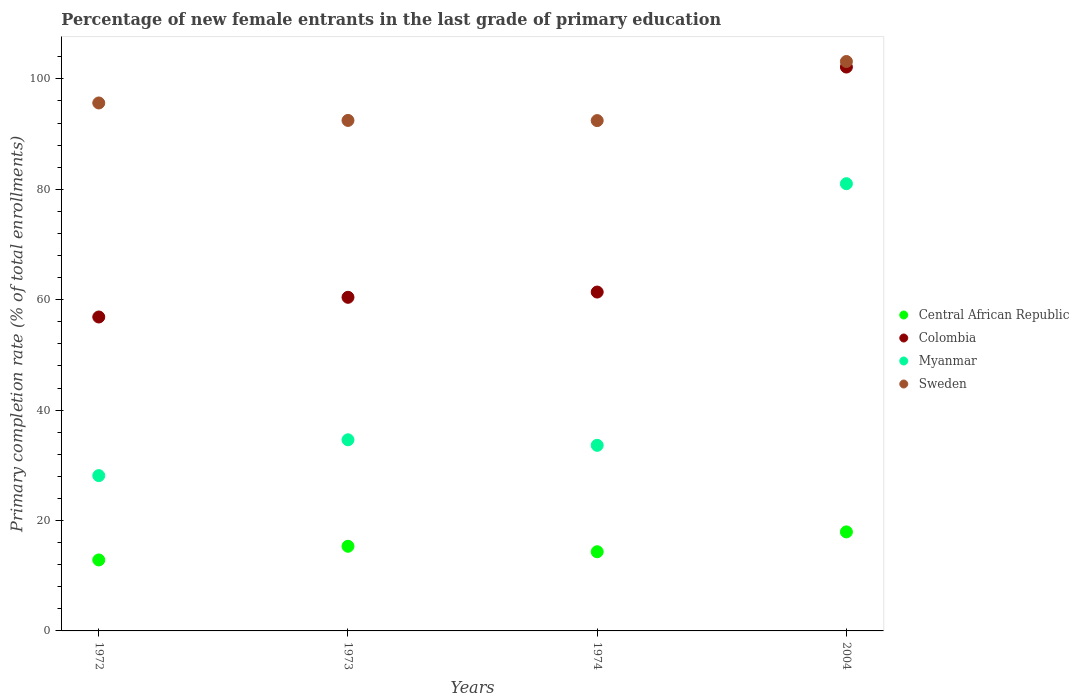Is the number of dotlines equal to the number of legend labels?
Make the answer very short. Yes. What is the percentage of new female entrants in Colombia in 1973?
Make the answer very short. 60.43. Across all years, what is the maximum percentage of new female entrants in Central African Republic?
Ensure brevity in your answer.  17.94. Across all years, what is the minimum percentage of new female entrants in Sweden?
Offer a terse response. 92.44. What is the total percentage of new female entrants in Central African Republic in the graph?
Provide a short and direct response. 60.47. What is the difference between the percentage of new female entrants in Colombia in 1972 and that in 2004?
Give a very brief answer. -45.28. What is the difference between the percentage of new female entrants in Myanmar in 1972 and the percentage of new female entrants in Sweden in 1974?
Ensure brevity in your answer.  -64.31. What is the average percentage of new female entrants in Colombia per year?
Ensure brevity in your answer.  70.21. In the year 1972, what is the difference between the percentage of new female entrants in Myanmar and percentage of new female entrants in Sweden?
Offer a very short reply. -67.5. What is the ratio of the percentage of new female entrants in Central African Republic in 1972 to that in 1974?
Your answer should be very brief. 0.9. Is the percentage of new female entrants in Sweden in 1972 less than that in 1973?
Make the answer very short. No. Is the difference between the percentage of new female entrants in Myanmar in 1972 and 2004 greater than the difference between the percentage of new female entrants in Sweden in 1972 and 2004?
Offer a terse response. No. What is the difference between the highest and the second highest percentage of new female entrants in Colombia?
Your answer should be compact. 40.76. What is the difference between the highest and the lowest percentage of new female entrants in Central African Republic?
Offer a very short reply. 5.08. In how many years, is the percentage of new female entrants in Colombia greater than the average percentage of new female entrants in Colombia taken over all years?
Give a very brief answer. 1. Is the sum of the percentage of new female entrants in Central African Republic in 1973 and 2004 greater than the maximum percentage of new female entrants in Sweden across all years?
Offer a very short reply. No. Is it the case that in every year, the sum of the percentage of new female entrants in Myanmar and percentage of new female entrants in Colombia  is greater than the sum of percentage of new female entrants in Central African Republic and percentage of new female entrants in Sweden?
Offer a very short reply. No. Does the percentage of new female entrants in Myanmar monotonically increase over the years?
Offer a very short reply. No. Is the percentage of new female entrants in Sweden strictly greater than the percentage of new female entrants in Colombia over the years?
Keep it short and to the point. Yes. Is the percentage of new female entrants in Myanmar strictly less than the percentage of new female entrants in Colombia over the years?
Provide a short and direct response. Yes. What is the difference between two consecutive major ticks on the Y-axis?
Your answer should be very brief. 20. Does the graph contain any zero values?
Offer a terse response. No. Where does the legend appear in the graph?
Keep it short and to the point. Center right. How are the legend labels stacked?
Provide a succinct answer. Vertical. What is the title of the graph?
Make the answer very short. Percentage of new female entrants in the last grade of primary education. What is the label or title of the X-axis?
Your response must be concise. Years. What is the label or title of the Y-axis?
Make the answer very short. Primary completion rate (% of total enrollments). What is the Primary completion rate (% of total enrollments) in Central African Republic in 1972?
Provide a succinct answer. 12.86. What is the Primary completion rate (% of total enrollments) of Colombia in 1972?
Keep it short and to the point. 56.87. What is the Primary completion rate (% of total enrollments) of Myanmar in 1972?
Keep it short and to the point. 28.13. What is the Primary completion rate (% of total enrollments) of Sweden in 1972?
Your answer should be very brief. 95.64. What is the Primary completion rate (% of total enrollments) of Central African Republic in 1973?
Your response must be concise. 15.33. What is the Primary completion rate (% of total enrollments) in Colombia in 1973?
Provide a short and direct response. 60.43. What is the Primary completion rate (% of total enrollments) of Myanmar in 1973?
Your answer should be very brief. 34.62. What is the Primary completion rate (% of total enrollments) in Sweden in 1973?
Provide a succinct answer. 92.47. What is the Primary completion rate (% of total enrollments) in Central African Republic in 1974?
Provide a succinct answer. 14.34. What is the Primary completion rate (% of total enrollments) in Colombia in 1974?
Provide a succinct answer. 61.39. What is the Primary completion rate (% of total enrollments) in Myanmar in 1974?
Keep it short and to the point. 33.62. What is the Primary completion rate (% of total enrollments) in Sweden in 1974?
Offer a very short reply. 92.44. What is the Primary completion rate (% of total enrollments) of Central African Republic in 2004?
Your answer should be compact. 17.94. What is the Primary completion rate (% of total enrollments) of Colombia in 2004?
Offer a very short reply. 102.14. What is the Primary completion rate (% of total enrollments) of Myanmar in 2004?
Your answer should be very brief. 81.01. What is the Primary completion rate (% of total enrollments) of Sweden in 2004?
Provide a succinct answer. 103.15. Across all years, what is the maximum Primary completion rate (% of total enrollments) of Central African Republic?
Keep it short and to the point. 17.94. Across all years, what is the maximum Primary completion rate (% of total enrollments) in Colombia?
Provide a short and direct response. 102.14. Across all years, what is the maximum Primary completion rate (% of total enrollments) in Myanmar?
Offer a terse response. 81.01. Across all years, what is the maximum Primary completion rate (% of total enrollments) in Sweden?
Make the answer very short. 103.15. Across all years, what is the minimum Primary completion rate (% of total enrollments) in Central African Republic?
Your answer should be compact. 12.86. Across all years, what is the minimum Primary completion rate (% of total enrollments) of Colombia?
Make the answer very short. 56.87. Across all years, what is the minimum Primary completion rate (% of total enrollments) of Myanmar?
Ensure brevity in your answer.  28.13. Across all years, what is the minimum Primary completion rate (% of total enrollments) in Sweden?
Provide a succinct answer. 92.44. What is the total Primary completion rate (% of total enrollments) of Central African Republic in the graph?
Your answer should be very brief. 60.47. What is the total Primary completion rate (% of total enrollments) of Colombia in the graph?
Give a very brief answer. 280.83. What is the total Primary completion rate (% of total enrollments) of Myanmar in the graph?
Offer a very short reply. 177.39. What is the total Primary completion rate (% of total enrollments) in Sweden in the graph?
Keep it short and to the point. 383.7. What is the difference between the Primary completion rate (% of total enrollments) of Central African Republic in 1972 and that in 1973?
Your answer should be compact. -2.48. What is the difference between the Primary completion rate (% of total enrollments) in Colombia in 1972 and that in 1973?
Keep it short and to the point. -3.57. What is the difference between the Primary completion rate (% of total enrollments) of Myanmar in 1972 and that in 1973?
Your response must be concise. -6.49. What is the difference between the Primary completion rate (% of total enrollments) of Sweden in 1972 and that in 1973?
Offer a very short reply. 3.16. What is the difference between the Primary completion rate (% of total enrollments) of Central African Republic in 1972 and that in 1974?
Give a very brief answer. -1.49. What is the difference between the Primary completion rate (% of total enrollments) in Colombia in 1972 and that in 1974?
Keep it short and to the point. -4.52. What is the difference between the Primary completion rate (% of total enrollments) of Myanmar in 1972 and that in 1974?
Your response must be concise. -5.49. What is the difference between the Primary completion rate (% of total enrollments) of Sweden in 1972 and that in 1974?
Ensure brevity in your answer.  3.19. What is the difference between the Primary completion rate (% of total enrollments) of Central African Republic in 1972 and that in 2004?
Your response must be concise. -5.08. What is the difference between the Primary completion rate (% of total enrollments) in Colombia in 1972 and that in 2004?
Ensure brevity in your answer.  -45.28. What is the difference between the Primary completion rate (% of total enrollments) of Myanmar in 1972 and that in 2004?
Make the answer very short. -52.88. What is the difference between the Primary completion rate (% of total enrollments) of Sweden in 1972 and that in 2004?
Ensure brevity in your answer.  -7.51. What is the difference between the Primary completion rate (% of total enrollments) of Central African Republic in 1973 and that in 1974?
Your answer should be very brief. 0.99. What is the difference between the Primary completion rate (% of total enrollments) of Colombia in 1973 and that in 1974?
Give a very brief answer. -0.95. What is the difference between the Primary completion rate (% of total enrollments) of Sweden in 1973 and that in 1974?
Your response must be concise. 0.03. What is the difference between the Primary completion rate (% of total enrollments) in Central African Republic in 1973 and that in 2004?
Make the answer very short. -2.6. What is the difference between the Primary completion rate (% of total enrollments) of Colombia in 1973 and that in 2004?
Provide a succinct answer. -41.71. What is the difference between the Primary completion rate (% of total enrollments) in Myanmar in 1973 and that in 2004?
Provide a succinct answer. -46.39. What is the difference between the Primary completion rate (% of total enrollments) in Sweden in 1973 and that in 2004?
Offer a terse response. -10.67. What is the difference between the Primary completion rate (% of total enrollments) of Central African Republic in 1974 and that in 2004?
Keep it short and to the point. -3.6. What is the difference between the Primary completion rate (% of total enrollments) in Colombia in 1974 and that in 2004?
Provide a short and direct response. -40.76. What is the difference between the Primary completion rate (% of total enrollments) in Myanmar in 1974 and that in 2004?
Offer a terse response. -47.39. What is the difference between the Primary completion rate (% of total enrollments) in Sweden in 1974 and that in 2004?
Offer a terse response. -10.7. What is the difference between the Primary completion rate (% of total enrollments) of Central African Republic in 1972 and the Primary completion rate (% of total enrollments) of Colombia in 1973?
Offer a very short reply. -47.58. What is the difference between the Primary completion rate (% of total enrollments) of Central African Republic in 1972 and the Primary completion rate (% of total enrollments) of Myanmar in 1973?
Your response must be concise. -21.77. What is the difference between the Primary completion rate (% of total enrollments) in Central African Republic in 1972 and the Primary completion rate (% of total enrollments) in Sweden in 1973?
Ensure brevity in your answer.  -79.62. What is the difference between the Primary completion rate (% of total enrollments) of Colombia in 1972 and the Primary completion rate (% of total enrollments) of Myanmar in 1973?
Offer a terse response. 22.25. What is the difference between the Primary completion rate (% of total enrollments) in Colombia in 1972 and the Primary completion rate (% of total enrollments) in Sweden in 1973?
Provide a succinct answer. -35.61. What is the difference between the Primary completion rate (% of total enrollments) of Myanmar in 1972 and the Primary completion rate (% of total enrollments) of Sweden in 1973?
Your response must be concise. -64.34. What is the difference between the Primary completion rate (% of total enrollments) of Central African Republic in 1972 and the Primary completion rate (% of total enrollments) of Colombia in 1974?
Give a very brief answer. -48.53. What is the difference between the Primary completion rate (% of total enrollments) in Central African Republic in 1972 and the Primary completion rate (% of total enrollments) in Myanmar in 1974?
Offer a terse response. -20.77. What is the difference between the Primary completion rate (% of total enrollments) in Central African Republic in 1972 and the Primary completion rate (% of total enrollments) in Sweden in 1974?
Give a very brief answer. -79.59. What is the difference between the Primary completion rate (% of total enrollments) of Colombia in 1972 and the Primary completion rate (% of total enrollments) of Myanmar in 1974?
Provide a short and direct response. 23.25. What is the difference between the Primary completion rate (% of total enrollments) of Colombia in 1972 and the Primary completion rate (% of total enrollments) of Sweden in 1974?
Give a very brief answer. -35.58. What is the difference between the Primary completion rate (% of total enrollments) of Myanmar in 1972 and the Primary completion rate (% of total enrollments) of Sweden in 1974?
Make the answer very short. -64.31. What is the difference between the Primary completion rate (% of total enrollments) in Central African Republic in 1972 and the Primary completion rate (% of total enrollments) in Colombia in 2004?
Ensure brevity in your answer.  -89.29. What is the difference between the Primary completion rate (% of total enrollments) of Central African Republic in 1972 and the Primary completion rate (% of total enrollments) of Myanmar in 2004?
Your response must be concise. -68.16. What is the difference between the Primary completion rate (% of total enrollments) in Central African Republic in 1972 and the Primary completion rate (% of total enrollments) in Sweden in 2004?
Your answer should be compact. -90.29. What is the difference between the Primary completion rate (% of total enrollments) in Colombia in 1972 and the Primary completion rate (% of total enrollments) in Myanmar in 2004?
Ensure brevity in your answer.  -24.14. What is the difference between the Primary completion rate (% of total enrollments) in Colombia in 1972 and the Primary completion rate (% of total enrollments) in Sweden in 2004?
Provide a succinct answer. -46.28. What is the difference between the Primary completion rate (% of total enrollments) in Myanmar in 1972 and the Primary completion rate (% of total enrollments) in Sweden in 2004?
Provide a short and direct response. -75.02. What is the difference between the Primary completion rate (% of total enrollments) in Central African Republic in 1973 and the Primary completion rate (% of total enrollments) in Colombia in 1974?
Provide a succinct answer. -46.05. What is the difference between the Primary completion rate (% of total enrollments) in Central African Republic in 1973 and the Primary completion rate (% of total enrollments) in Myanmar in 1974?
Ensure brevity in your answer.  -18.29. What is the difference between the Primary completion rate (% of total enrollments) of Central African Republic in 1973 and the Primary completion rate (% of total enrollments) of Sweden in 1974?
Keep it short and to the point. -77.11. What is the difference between the Primary completion rate (% of total enrollments) in Colombia in 1973 and the Primary completion rate (% of total enrollments) in Myanmar in 1974?
Your answer should be compact. 26.81. What is the difference between the Primary completion rate (% of total enrollments) in Colombia in 1973 and the Primary completion rate (% of total enrollments) in Sweden in 1974?
Your answer should be very brief. -32.01. What is the difference between the Primary completion rate (% of total enrollments) in Myanmar in 1973 and the Primary completion rate (% of total enrollments) in Sweden in 1974?
Your answer should be compact. -57.82. What is the difference between the Primary completion rate (% of total enrollments) of Central African Republic in 1973 and the Primary completion rate (% of total enrollments) of Colombia in 2004?
Your answer should be very brief. -86.81. What is the difference between the Primary completion rate (% of total enrollments) of Central African Republic in 1973 and the Primary completion rate (% of total enrollments) of Myanmar in 2004?
Give a very brief answer. -65.68. What is the difference between the Primary completion rate (% of total enrollments) in Central African Republic in 1973 and the Primary completion rate (% of total enrollments) in Sweden in 2004?
Ensure brevity in your answer.  -87.81. What is the difference between the Primary completion rate (% of total enrollments) in Colombia in 1973 and the Primary completion rate (% of total enrollments) in Myanmar in 2004?
Keep it short and to the point. -20.58. What is the difference between the Primary completion rate (% of total enrollments) in Colombia in 1973 and the Primary completion rate (% of total enrollments) in Sweden in 2004?
Provide a succinct answer. -42.72. What is the difference between the Primary completion rate (% of total enrollments) in Myanmar in 1973 and the Primary completion rate (% of total enrollments) in Sweden in 2004?
Your answer should be very brief. -68.53. What is the difference between the Primary completion rate (% of total enrollments) in Central African Republic in 1974 and the Primary completion rate (% of total enrollments) in Colombia in 2004?
Give a very brief answer. -87.8. What is the difference between the Primary completion rate (% of total enrollments) of Central African Republic in 1974 and the Primary completion rate (% of total enrollments) of Myanmar in 2004?
Make the answer very short. -66.67. What is the difference between the Primary completion rate (% of total enrollments) of Central African Republic in 1974 and the Primary completion rate (% of total enrollments) of Sweden in 2004?
Keep it short and to the point. -88.81. What is the difference between the Primary completion rate (% of total enrollments) of Colombia in 1974 and the Primary completion rate (% of total enrollments) of Myanmar in 2004?
Your answer should be compact. -19.63. What is the difference between the Primary completion rate (% of total enrollments) of Colombia in 1974 and the Primary completion rate (% of total enrollments) of Sweden in 2004?
Give a very brief answer. -41.76. What is the difference between the Primary completion rate (% of total enrollments) in Myanmar in 1974 and the Primary completion rate (% of total enrollments) in Sweden in 2004?
Provide a succinct answer. -69.53. What is the average Primary completion rate (% of total enrollments) of Central African Republic per year?
Provide a succinct answer. 15.12. What is the average Primary completion rate (% of total enrollments) in Colombia per year?
Your answer should be very brief. 70.21. What is the average Primary completion rate (% of total enrollments) in Myanmar per year?
Make the answer very short. 44.35. What is the average Primary completion rate (% of total enrollments) of Sweden per year?
Your answer should be very brief. 95.93. In the year 1972, what is the difference between the Primary completion rate (% of total enrollments) of Central African Republic and Primary completion rate (% of total enrollments) of Colombia?
Your answer should be very brief. -44.01. In the year 1972, what is the difference between the Primary completion rate (% of total enrollments) in Central African Republic and Primary completion rate (% of total enrollments) in Myanmar?
Your answer should be very brief. -15.28. In the year 1972, what is the difference between the Primary completion rate (% of total enrollments) in Central African Republic and Primary completion rate (% of total enrollments) in Sweden?
Offer a terse response. -82.78. In the year 1972, what is the difference between the Primary completion rate (% of total enrollments) in Colombia and Primary completion rate (% of total enrollments) in Myanmar?
Your response must be concise. 28.73. In the year 1972, what is the difference between the Primary completion rate (% of total enrollments) of Colombia and Primary completion rate (% of total enrollments) of Sweden?
Offer a terse response. -38.77. In the year 1972, what is the difference between the Primary completion rate (% of total enrollments) of Myanmar and Primary completion rate (% of total enrollments) of Sweden?
Offer a terse response. -67.5. In the year 1973, what is the difference between the Primary completion rate (% of total enrollments) of Central African Republic and Primary completion rate (% of total enrollments) of Colombia?
Offer a terse response. -45.1. In the year 1973, what is the difference between the Primary completion rate (% of total enrollments) of Central African Republic and Primary completion rate (% of total enrollments) of Myanmar?
Your response must be concise. -19.29. In the year 1973, what is the difference between the Primary completion rate (% of total enrollments) in Central African Republic and Primary completion rate (% of total enrollments) in Sweden?
Provide a short and direct response. -77.14. In the year 1973, what is the difference between the Primary completion rate (% of total enrollments) of Colombia and Primary completion rate (% of total enrollments) of Myanmar?
Your answer should be very brief. 25.81. In the year 1973, what is the difference between the Primary completion rate (% of total enrollments) in Colombia and Primary completion rate (% of total enrollments) in Sweden?
Provide a succinct answer. -32.04. In the year 1973, what is the difference between the Primary completion rate (% of total enrollments) of Myanmar and Primary completion rate (% of total enrollments) of Sweden?
Give a very brief answer. -57.85. In the year 1974, what is the difference between the Primary completion rate (% of total enrollments) of Central African Republic and Primary completion rate (% of total enrollments) of Colombia?
Make the answer very short. -47.04. In the year 1974, what is the difference between the Primary completion rate (% of total enrollments) in Central African Republic and Primary completion rate (% of total enrollments) in Myanmar?
Your answer should be compact. -19.28. In the year 1974, what is the difference between the Primary completion rate (% of total enrollments) of Central African Republic and Primary completion rate (% of total enrollments) of Sweden?
Your answer should be compact. -78.1. In the year 1974, what is the difference between the Primary completion rate (% of total enrollments) in Colombia and Primary completion rate (% of total enrollments) in Myanmar?
Your answer should be very brief. 27.76. In the year 1974, what is the difference between the Primary completion rate (% of total enrollments) in Colombia and Primary completion rate (% of total enrollments) in Sweden?
Ensure brevity in your answer.  -31.06. In the year 1974, what is the difference between the Primary completion rate (% of total enrollments) in Myanmar and Primary completion rate (% of total enrollments) in Sweden?
Your answer should be very brief. -58.82. In the year 2004, what is the difference between the Primary completion rate (% of total enrollments) in Central African Republic and Primary completion rate (% of total enrollments) in Colombia?
Offer a very short reply. -84.21. In the year 2004, what is the difference between the Primary completion rate (% of total enrollments) of Central African Republic and Primary completion rate (% of total enrollments) of Myanmar?
Your answer should be very brief. -63.07. In the year 2004, what is the difference between the Primary completion rate (% of total enrollments) in Central African Republic and Primary completion rate (% of total enrollments) in Sweden?
Provide a succinct answer. -85.21. In the year 2004, what is the difference between the Primary completion rate (% of total enrollments) in Colombia and Primary completion rate (% of total enrollments) in Myanmar?
Your answer should be compact. 21.13. In the year 2004, what is the difference between the Primary completion rate (% of total enrollments) of Colombia and Primary completion rate (% of total enrollments) of Sweden?
Your answer should be very brief. -1. In the year 2004, what is the difference between the Primary completion rate (% of total enrollments) in Myanmar and Primary completion rate (% of total enrollments) in Sweden?
Give a very brief answer. -22.14. What is the ratio of the Primary completion rate (% of total enrollments) of Central African Republic in 1972 to that in 1973?
Your answer should be very brief. 0.84. What is the ratio of the Primary completion rate (% of total enrollments) in Colombia in 1972 to that in 1973?
Make the answer very short. 0.94. What is the ratio of the Primary completion rate (% of total enrollments) of Myanmar in 1972 to that in 1973?
Your answer should be compact. 0.81. What is the ratio of the Primary completion rate (% of total enrollments) of Sweden in 1972 to that in 1973?
Your answer should be very brief. 1.03. What is the ratio of the Primary completion rate (% of total enrollments) of Central African Republic in 1972 to that in 1974?
Give a very brief answer. 0.9. What is the ratio of the Primary completion rate (% of total enrollments) of Colombia in 1972 to that in 1974?
Make the answer very short. 0.93. What is the ratio of the Primary completion rate (% of total enrollments) in Myanmar in 1972 to that in 1974?
Offer a very short reply. 0.84. What is the ratio of the Primary completion rate (% of total enrollments) of Sweden in 1972 to that in 1974?
Your answer should be compact. 1.03. What is the ratio of the Primary completion rate (% of total enrollments) of Central African Republic in 1972 to that in 2004?
Give a very brief answer. 0.72. What is the ratio of the Primary completion rate (% of total enrollments) in Colombia in 1972 to that in 2004?
Provide a succinct answer. 0.56. What is the ratio of the Primary completion rate (% of total enrollments) in Myanmar in 1972 to that in 2004?
Your answer should be compact. 0.35. What is the ratio of the Primary completion rate (% of total enrollments) in Sweden in 1972 to that in 2004?
Offer a terse response. 0.93. What is the ratio of the Primary completion rate (% of total enrollments) of Central African Republic in 1973 to that in 1974?
Ensure brevity in your answer.  1.07. What is the ratio of the Primary completion rate (% of total enrollments) in Colombia in 1973 to that in 1974?
Your response must be concise. 0.98. What is the ratio of the Primary completion rate (% of total enrollments) of Myanmar in 1973 to that in 1974?
Your response must be concise. 1.03. What is the ratio of the Primary completion rate (% of total enrollments) in Central African Republic in 1973 to that in 2004?
Make the answer very short. 0.85. What is the ratio of the Primary completion rate (% of total enrollments) of Colombia in 1973 to that in 2004?
Ensure brevity in your answer.  0.59. What is the ratio of the Primary completion rate (% of total enrollments) in Myanmar in 1973 to that in 2004?
Your response must be concise. 0.43. What is the ratio of the Primary completion rate (% of total enrollments) in Sweden in 1973 to that in 2004?
Provide a succinct answer. 0.9. What is the ratio of the Primary completion rate (% of total enrollments) in Central African Republic in 1974 to that in 2004?
Ensure brevity in your answer.  0.8. What is the ratio of the Primary completion rate (% of total enrollments) of Colombia in 1974 to that in 2004?
Your answer should be compact. 0.6. What is the ratio of the Primary completion rate (% of total enrollments) of Myanmar in 1974 to that in 2004?
Give a very brief answer. 0.41. What is the ratio of the Primary completion rate (% of total enrollments) in Sweden in 1974 to that in 2004?
Provide a succinct answer. 0.9. What is the difference between the highest and the second highest Primary completion rate (% of total enrollments) of Central African Republic?
Your response must be concise. 2.6. What is the difference between the highest and the second highest Primary completion rate (% of total enrollments) of Colombia?
Offer a very short reply. 40.76. What is the difference between the highest and the second highest Primary completion rate (% of total enrollments) of Myanmar?
Your response must be concise. 46.39. What is the difference between the highest and the second highest Primary completion rate (% of total enrollments) in Sweden?
Provide a succinct answer. 7.51. What is the difference between the highest and the lowest Primary completion rate (% of total enrollments) of Central African Republic?
Give a very brief answer. 5.08. What is the difference between the highest and the lowest Primary completion rate (% of total enrollments) in Colombia?
Provide a succinct answer. 45.28. What is the difference between the highest and the lowest Primary completion rate (% of total enrollments) in Myanmar?
Make the answer very short. 52.88. What is the difference between the highest and the lowest Primary completion rate (% of total enrollments) of Sweden?
Give a very brief answer. 10.7. 